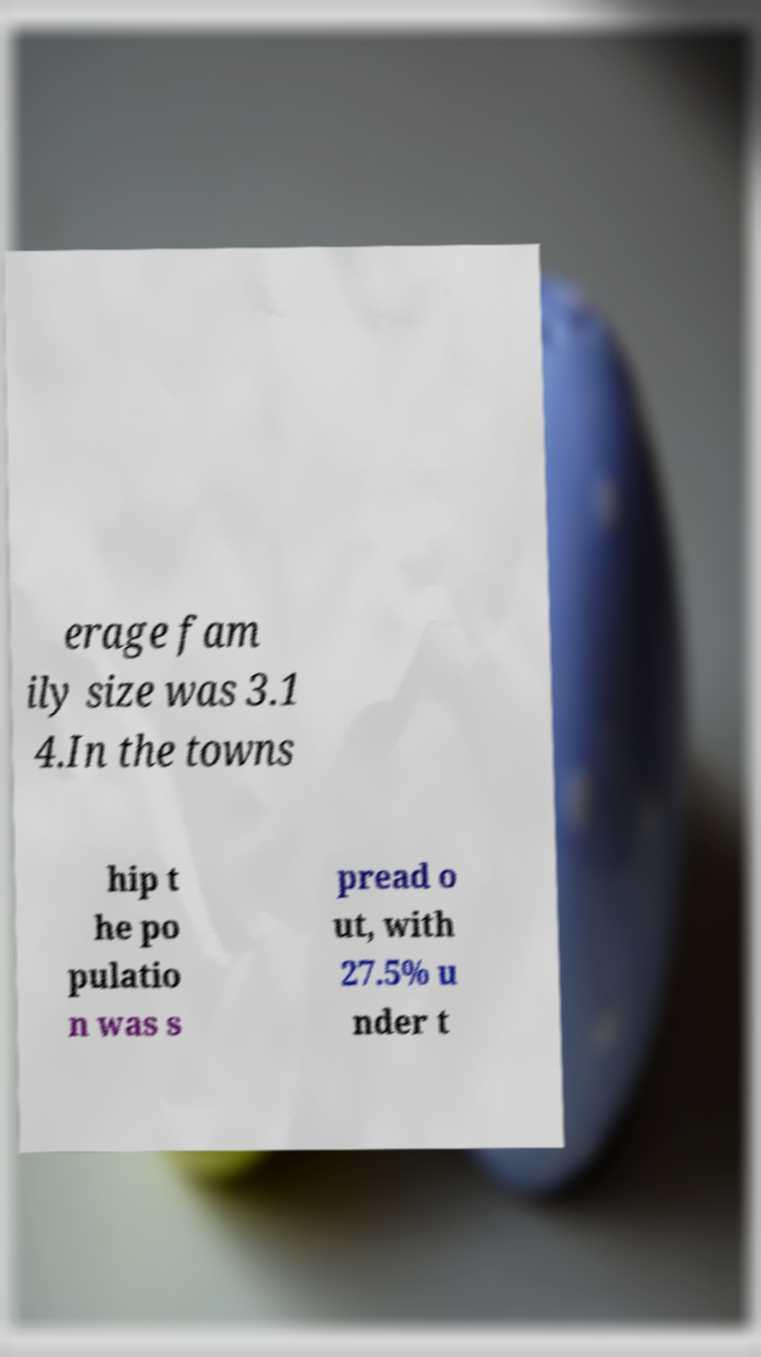Could you assist in decoding the text presented in this image and type it out clearly? erage fam ily size was 3.1 4.In the towns hip t he po pulatio n was s pread o ut, with 27.5% u nder t 